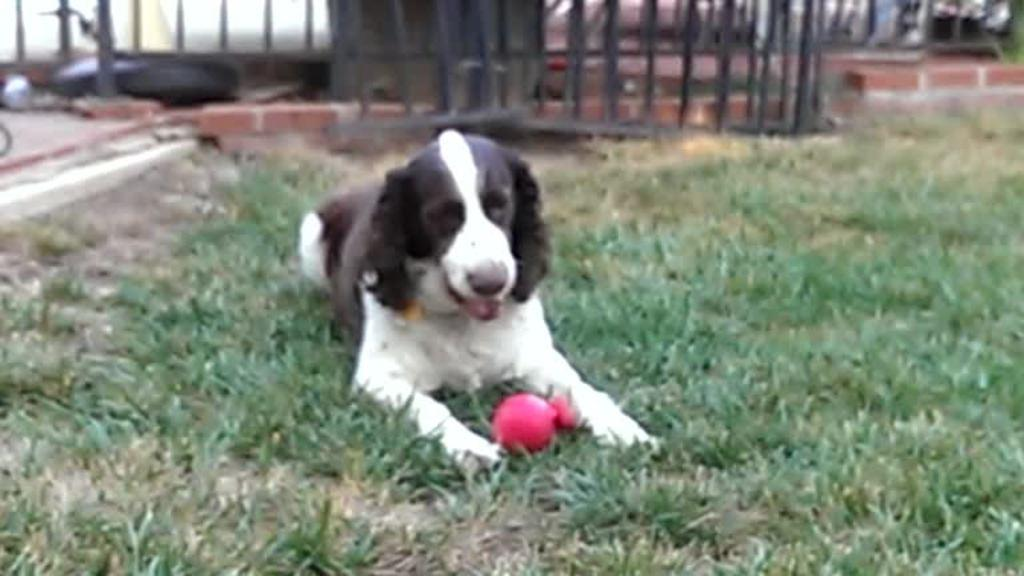What type of animal is in the image? There is a black and white dog in the image. Where is the dog located? The dog is sitting on the grass. What can be seen in the background of the image? There is fencing at the back of the image. What type of show is the dog participating in within the image? There is no indication of a show or any performance in the image; it simply shows a dog sitting on the grass. 